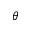<formula> <loc_0><loc_0><loc_500><loc_500>\theta</formula> 